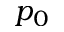<formula> <loc_0><loc_0><loc_500><loc_500>p _ { 0 }</formula> 